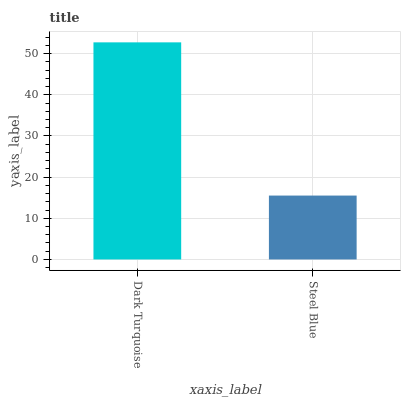Is Steel Blue the minimum?
Answer yes or no. Yes. Is Dark Turquoise the maximum?
Answer yes or no. Yes. Is Steel Blue the maximum?
Answer yes or no. No. Is Dark Turquoise greater than Steel Blue?
Answer yes or no. Yes. Is Steel Blue less than Dark Turquoise?
Answer yes or no. Yes. Is Steel Blue greater than Dark Turquoise?
Answer yes or no. No. Is Dark Turquoise less than Steel Blue?
Answer yes or no. No. Is Dark Turquoise the high median?
Answer yes or no. Yes. Is Steel Blue the low median?
Answer yes or no. Yes. Is Steel Blue the high median?
Answer yes or no. No. Is Dark Turquoise the low median?
Answer yes or no. No. 